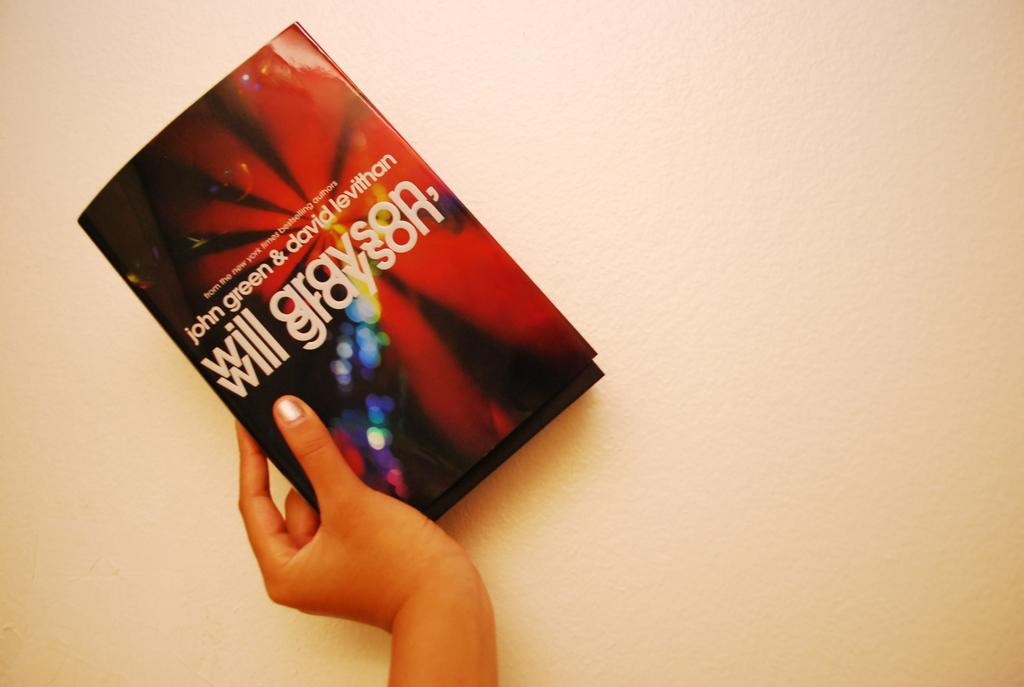<image>
Share a concise interpretation of the image provided. A hand is holding the book Will Grayson, a co-authored book. 